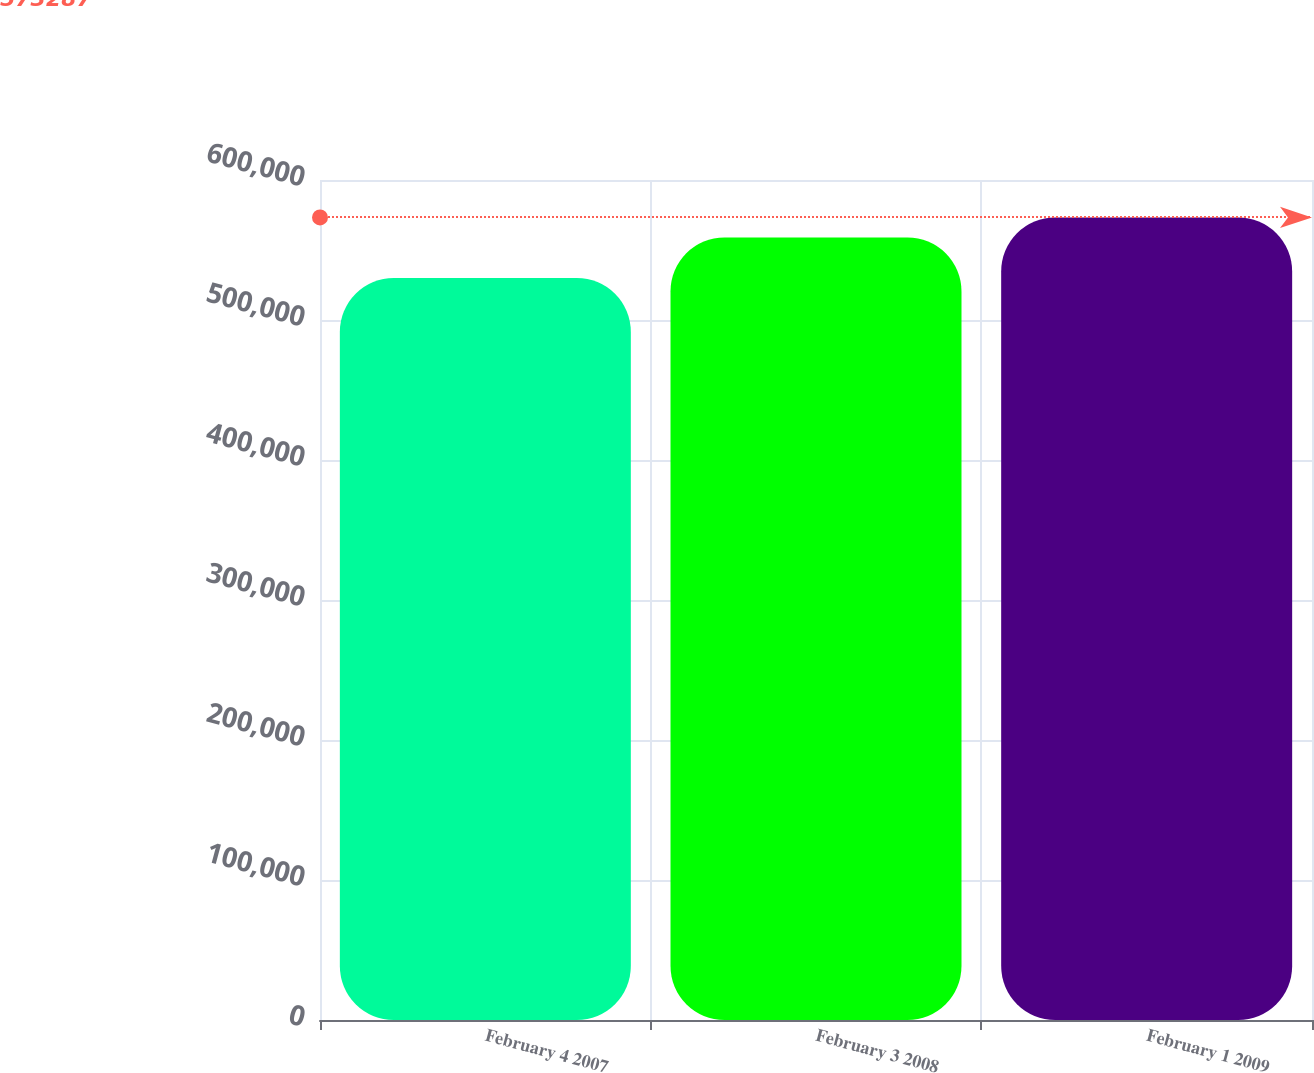Convert chart. <chart><loc_0><loc_0><loc_500><loc_500><bar_chart><fcel>February 4 2007<fcel>February 3 2008<fcel>February 1 2009<nl><fcel>530002<fcel>558960<fcel>573287<nl></chart> 